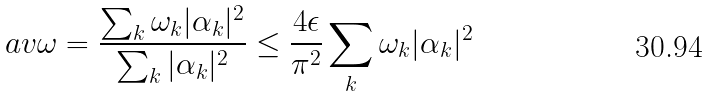<formula> <loc_0><loc_0><loc_500><loc_500>\ a v { \omega } = \frac { \sum _ { k } \omega _ { k } | \alpha _ { k } | ^ { 2 } } { \sum _ { k } | \alpha _ { k } | ^ { 2 } } \leq \frac { 4 \epsilon } { \pi ^ { 2 } } \sum _ { k } \omega _ { k } | \alpha _ { k } | ^ { 2 }</formula> 